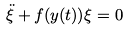<formula> <loc_0><loc_0><loc_500><loc_500>\ddot { \xi } + f ( y ( t ) ) \xi = 0</formula> 